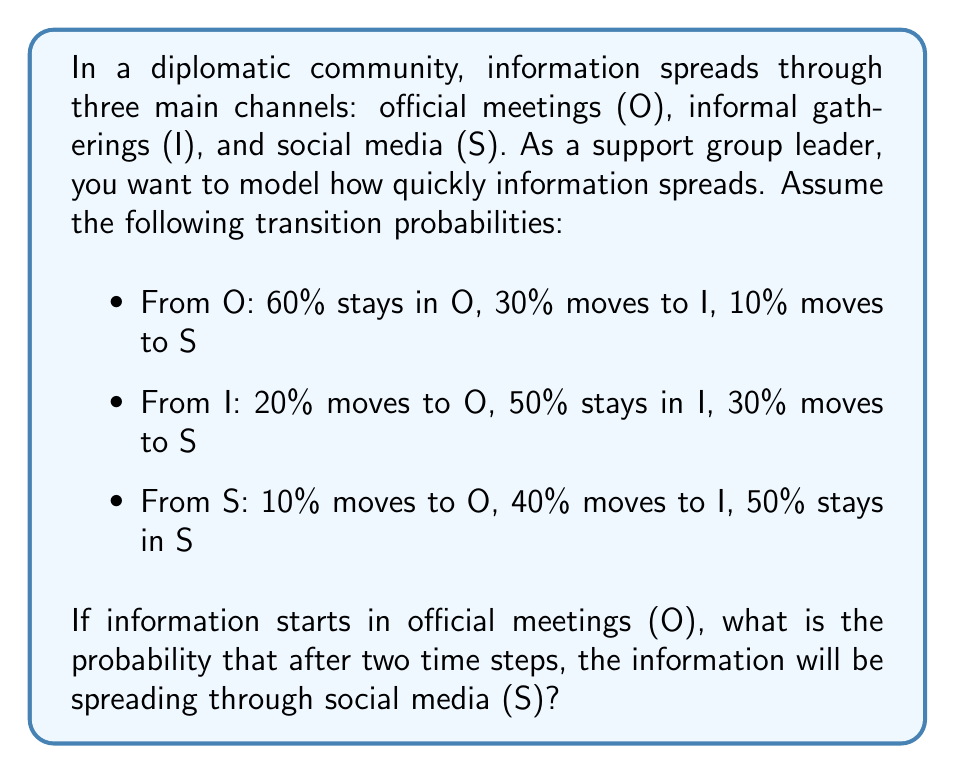Show me your answer to this math problem. Let's approach this step-by-step using a Markov chain:

1) First, we need to set up the transition matrix P:

   $$P = \begin{bmatrix}
   0.6 & 0.3 & 0.1 \\
   0.2 & 0.5 & 0.3 \\
   0.1 & 0.4 & 0.5
   \end{bmatrix}$$

2) The initial state vector is:

   $$v_0 = \begin{bmatrix} 1 \\ 0 \\ 0 \end{bmatrix}$$

   because the information starts in official meetings (O).

3) To find the state after two time steps, we need to multiply the initial state by the transition matrix twice:

   $$v_2 = P^2 v_0$$

4) Let's calculate $P^2$:

   $$P^2 = \begin{bmatrix}
   0.6 & 0.3 & 0.1 \\
   0.2 & 0.5 & 0.3 \\
   0.1 & 0.4 & 0.5
   \end{bmatrix} \times \begin{bmatrix}
   0.6 & 0.3 & 0.1 \\
   0.2 & 0.5 & 0.3 \\
   0.1 & 0.4 & 0.5
   \end{bmatrix}$$

5) Multiplying these matrices:

   $$P^2 = \begin{bmatrix}
   0.41 & 0.37 & 0.22 \\
   0.23 & 0.46 & 0.31 \\
   0.17 & 0.42 & 0.41
   \end{bmatrix}$$

6) Now, we multiply $P^2$ by $v_0$:

   $$v_2 = P^2 v_0 = \begin{bmatrix}
   0.41 & 0.37 & 0.22 \\
   0.23 & 0.46 & 0.31 \\
   0.17 & 0.42 & 0.41
   \end{bmatrix} \times \begin{bmatrix} 1 \\ 0 \\ 0 \end{bmatrix} = \begin{bmatrix} 0.41 \\ 0.23 \\ 0.17 \end{bmatrix}$$

7) The probability that the information will be in state S after two time steps is the third element of this vector: 0.17 or 17%.
Answer: 0.17 